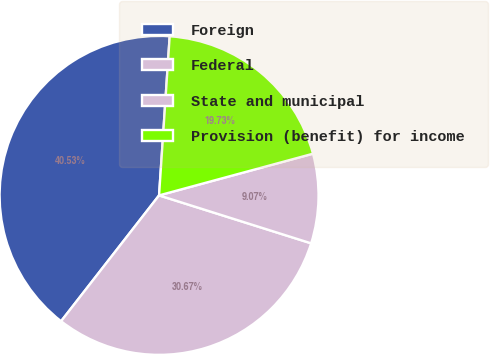Convert chart to OTSL. <chart><loc_0><loc_0><loc_500><loc_500><pie_chart><fcel>Foreign<fcel>Federal<fcel>State and municipal<fcel>Provision (benefit) for income<nl><fcel>40.53%<fcel>30.67%<fcel>9.07%<fcel>19.73%<nl></chart> 